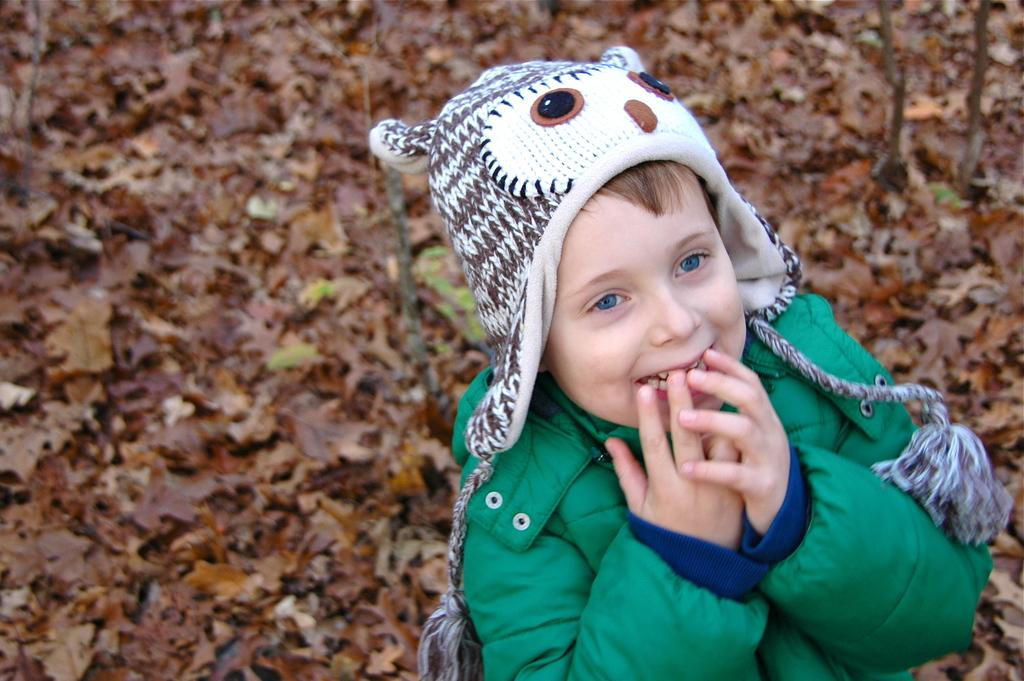What is the main subject of the image? The main subject of the image is a kid standing. What is the kid wearing on their head? The kid is wearing a hat. What type of clothing is the kid wearing on their upper body? The kid is wearing a jacket. What can be seen on the ground in the background of the image? There are dried leaves on the ground in the background of the image. What type of apparatus is being used by the kid to generate steam in the image? There is no apparatus or steam present in the image; it only features a kid standing with a hat and jacket. 